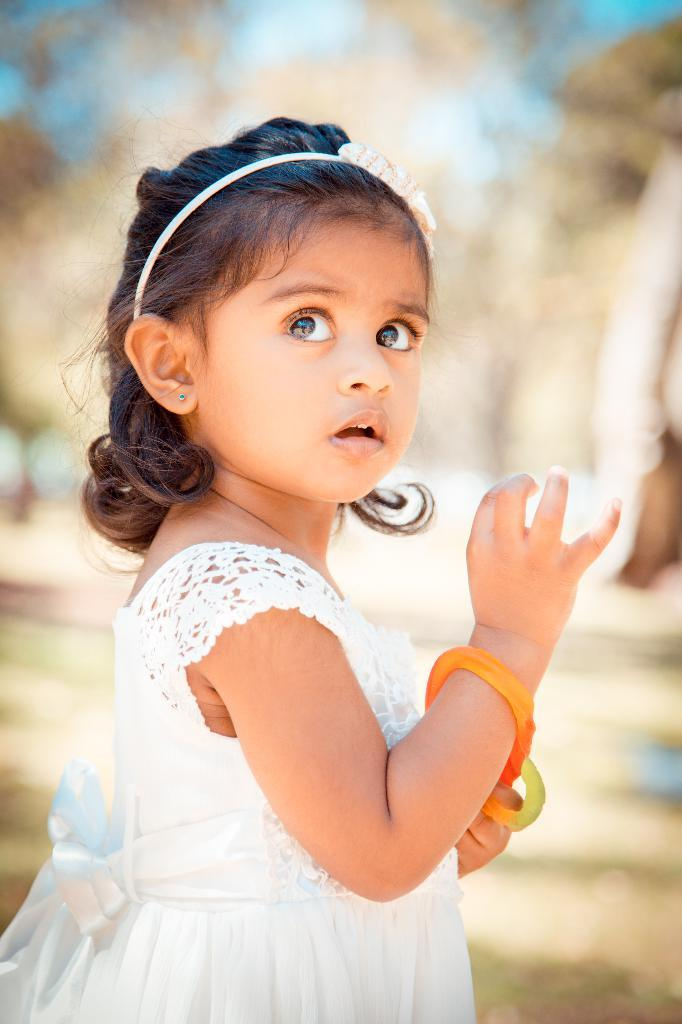What is the main subject of the image? There is a girl child in the image. What accessories is the girl child wearing? The girl child is wearing bangles and a hair band. How would you describe the background of the image? The background of the image is blurry. What type of hair is the manager using to create the shade in the image? There is no manager or shade present in the image; it features a girl child wearing bangles and a hair band with a blurry background. 